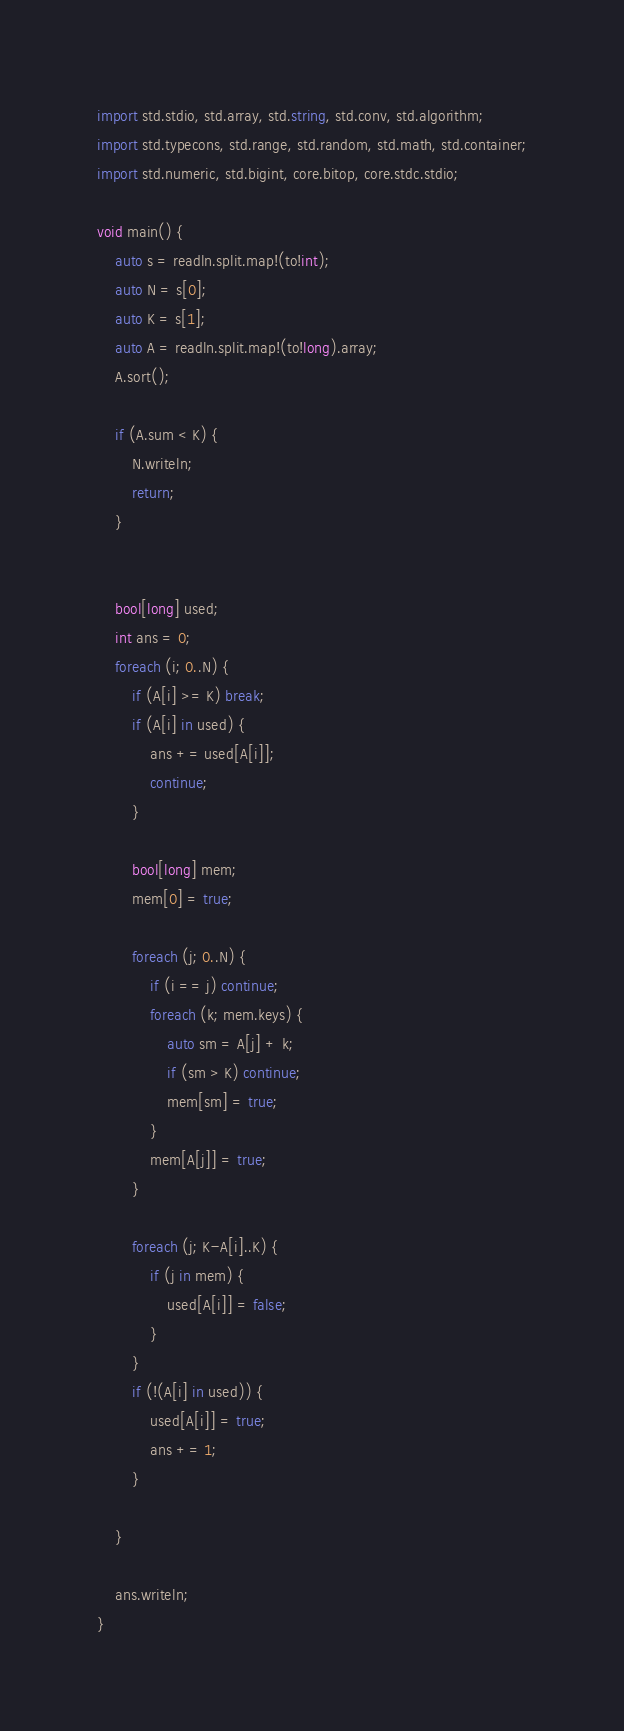<code> <loc_0><loc_0><loc_500><loc_500><_D_>import std.stdio, std.array, std.string, std.conv, std.algorithm;
import std.typecons, std.range, std.random, std.math, std.container;
import std.numeric, std.bigint, core.bitop, core.stdc.stdio;

void main() {
    auto s = readln.split.map!(to!int);
    auto N = s[0];
    auto K = s[1];
    auto A = readln.split.map!(to!long).array;
    A.sort();

    if (A.sum < K) {
        N.writeln;
        return;
    }


    bool[long] used;
    int ans = 0;
    foreach (i; 0..N) {
        if (A[i] >= K) break;
        if (A[i] in used) {
            ans += used[A[i]];
            continue;
        }

        bool[long] mem;
        mem[0] = true;

        foreach (j; 0..N) {
            if (i == j) continue;
            foreach (k; mem.keys) {
                auto sm = A[j] + k;
                if (sm > K) continue;
                mem[sm] = true;
            }
            mem[A[j]] = true;
        }

        foreach (j; K-A[i]..K) {
            if (j in mem) {
                used[A[i]] = false;
            }
        }
        if (!(A[i] in used)) {
            used[A[i]] = true;
            ans += 1;
        }

    }

    ans.writeln;
}
</code> 